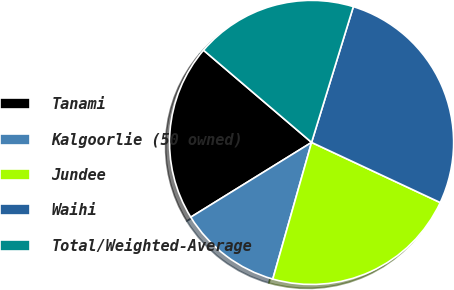<chart> <loc_0><loc_0><loc_500><loc_500><pie_chart><fcel>Tanami<fcel>Kalgoorlie (50 owned)<fcel>Jundee<fcel>Waihi<fcel>Total/Weighted-Average<nl><fcel>20.06%<fcel>11.78%<fcel>22.44%<fcel>27.21%<fcel>18.51%<nl></chart> 